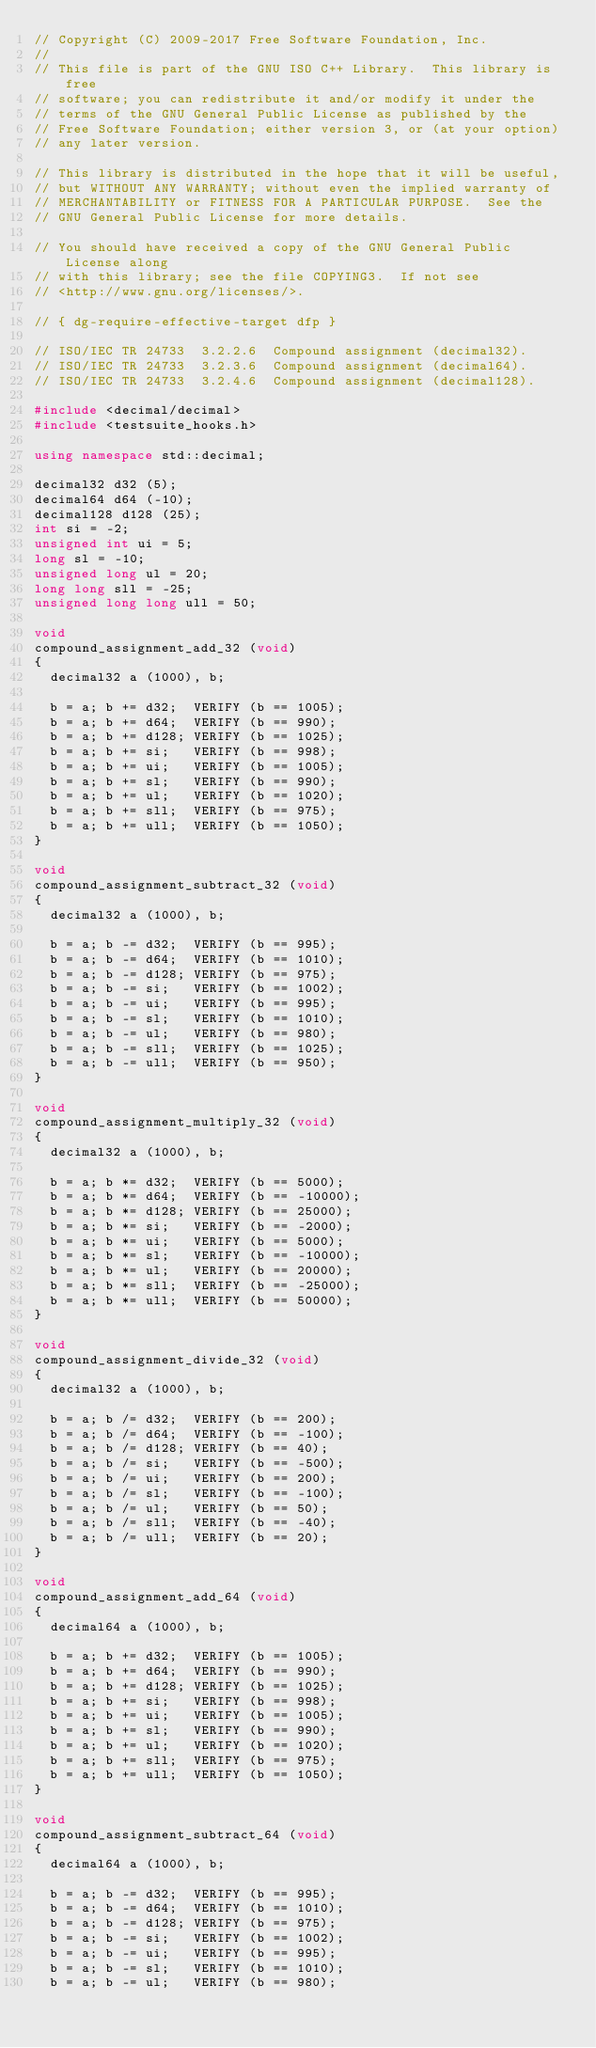Convert code to text. <code><loc_0><loc_0><loc_500><loc_500><_C++_>// Copyright (C) 2009-2017 Free Software Foundation, Inc.
//
// This file is part of the GNU ISO C++ Library.  This library is free
// software; you can redistribute it and/or modify it under the
// terms of the GNU General Public License as published by the
// Free Software Foundation; either version 3, or (at your option)
// any later version.

// This library is distributed in the hope that it will be useful,
// but WITHOUT ANY WARRANTY; without even the implied warranty of
// MERCHANTABILITY or FITNESS FOR A PARTICULAR PURPOSE.  See the
// GNU General Public License for more details.

// You should have received a copy of the GNU General Public License along
// with this library; see the file COPYING3.  If not see
// <http://www.gnu.org/licenses/>.

// { dg-require-effective-target dfp }

// ISO/IEC TR 24733  3.2.2.6  Compound assignment (decimal32).
// ISO/IEC TR 24733  3.2.3.6  Compound assignment (decimal64).
// ISO/IEC TR 24733  3.2.4.6  Compound assignment (decimal128).

#include <decimal/decimal>
#include <testsuite_hooks.h>

using namespace std::decimal;

decimal32 d32 (5);
decimal64 d64 (-10);
decimal128 d128 (25);
int si = -2;
unsigned int ui = 5;
long sl = -10;
unsigned long ul = 20;
long long sll = -25;
unsigned long long ull = 50;

void
compound_assignment_add_32 (void)
{
  decimal32 a (1000), b;

  b = a; b += d32;  VERIFY (b == 1005);
  b = a; b += d64;  VERIFY (b == 990);
  b = a; b += d128; VERIFY (b == 1025);
  b = a; b += si;   VERIFY (b == 998);
  b = a; b += ui;   VERIFY (b == 1005);
  b = a; b += sl;   VERIFY (b == 990);
  b = a; b += ul;   VERIFY (b == 1020);
  b = a; b += sll;  VERIFY (b == 975);
  b = a; b += ull;  VERIFY (b == 1050);
}

void
compound_assignment_subtract_32 (void)
{
  decimal32 a (1000), b;

  b = a; b -= d32;  VERIFY (b == 995);
  b = a; b -= d64;  VERIFY (b == 1010);
  b = a; b -= d128; VERIFY (b == 975);
  b = a; b -= si;   VERIFY (b == 1002);
  b = a; b -= ui;   VERIFY (b == 995);
  b = a; b -= sl;   VERIFY (b == 1010);
  b = a; b -= ul;   VERIFY (b == 980);
  b = a; b -= sll;  VERIFY (b == 1025);
  b = a; b -= ull;  VERIFY (b == 950);
}

void
compound_assignment_multiply_32 (void)
{
  decimal32 a (1000), b;

  b = a; b *= d32;  VERIFY (b == 5000);
  b = a; b *= d64;  VERIFY (b == -10000);
  b = a; b *= d128; VERIFY (b == 25000);
  b = a; b *= si;   VERIFY (b == -2000);
  b = a; b *= ui;   VERIFY (b == 5000);
  b = a; b *= sl;   VERIFY (b == -10000);
  b = a; b *= ul;   VERIFY (b == 20000);
  b = a; b *= sll;  VERIFY (b == -25000);
  b = a; b *= ull;  VERIFY (b == 50000);
}

void
compound_assignment_divide_32 (void)
{
  decimal32 a (1000), b;

  b = a; b /= d32;  VERIFY (b == 200);
  b = a; b /= d64;  VERIFY (b == -100);
  b = a; b /= d128; VERIFY (b == 40);
  b = a; b /= si;   VERIFY (b == -500);
  b = a; b /= ui;   VERIFY (b == 200);
  b = a; b /= sl;   VERIFY (b == -100);
  b = a; b /= ul;   VERIFY (b == 50);
  b = a; b /= sll;  VERIFY (b == -40);
  b = a; b /= ull;  VERIFY (b == 20);
}

void
compound_assignment_add_64 (void)
{
  decimal64 a (1000), b;

  b = a; b += d32;  VERIFY (b == 1005);
  b = a; b += d64;  VERIFY (b == 990);
  b = a; b += d128; VERIFY (b == 1025);
  b = a; b += si;   VERIFY (b == 998);
  b = a; b += ui;   VERIFY (b == 1005);
  b = a; b += sl;   VERIFY (b == 990);
  b = a; b += ul;   VERIFY (b == 1020);
  b = a; b += sll;  VERIFY (b == 975);
  b = a; b += ull;  VERIFY (b == 1050);
}

void
compound_assignment_subtract_64 (void)
{
  decimal64 a (1000), b;

  b = a; b -= d32;  VERIFY (b == 995);
  b = a; b -= d64;  VERIFY (b == 1010);
  b = a; b -= d128; VERIFY (b == 975);
  b = a; b -= si;   VERIFY (b == 1002);
  b = a; b -= ui;   VERIFY (b == 995);
  b = a; b -= sl;   VERIFY (b == 1010);
  b = a; b -= ul;   VERIFY (b == 980);</code> 